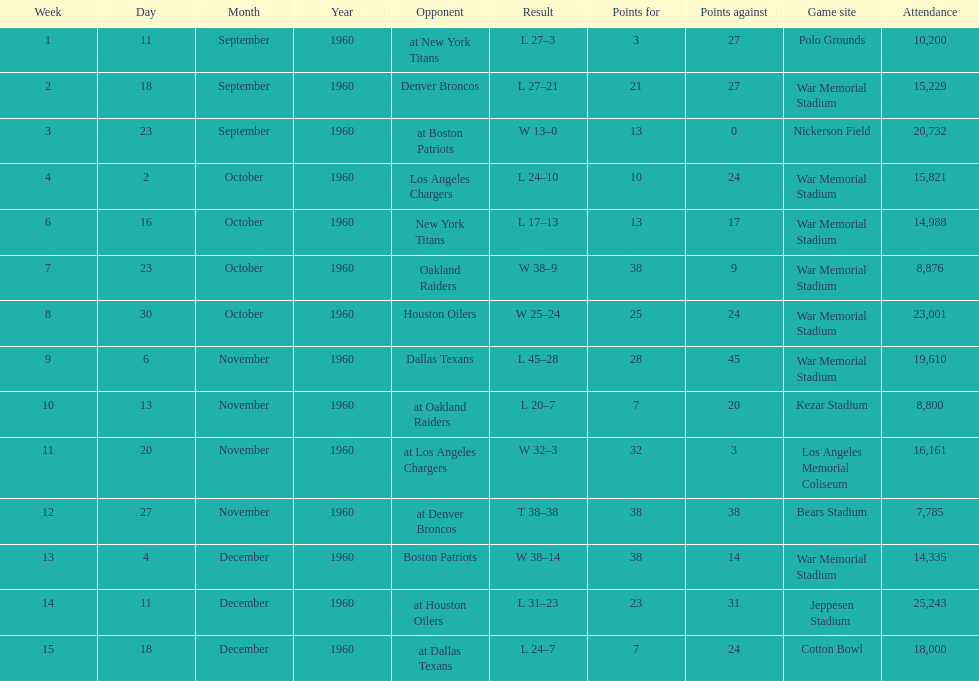What date was the first game at war memorial stadium? September 18, 1960. 